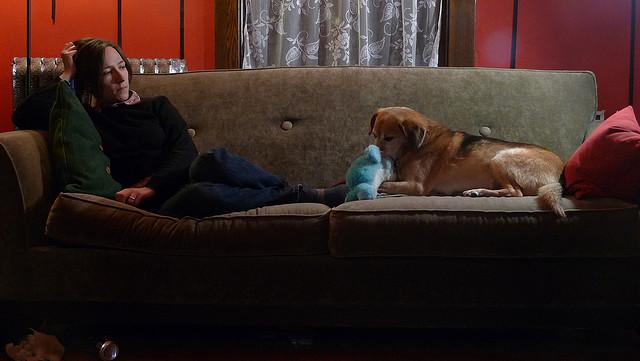Where is the dog looking?
Short answer required. Down. What is the dog doing to the stuffed animal?
Short answer required. Chewing. What type of dog is this?
Keep it brief. Mutt. What color pillow is next to the dog?
Write a very short answer. Red. What color is the dog?
Quick response, please. Brown. Does the woman look happy?
Give a very brief answer. No. 